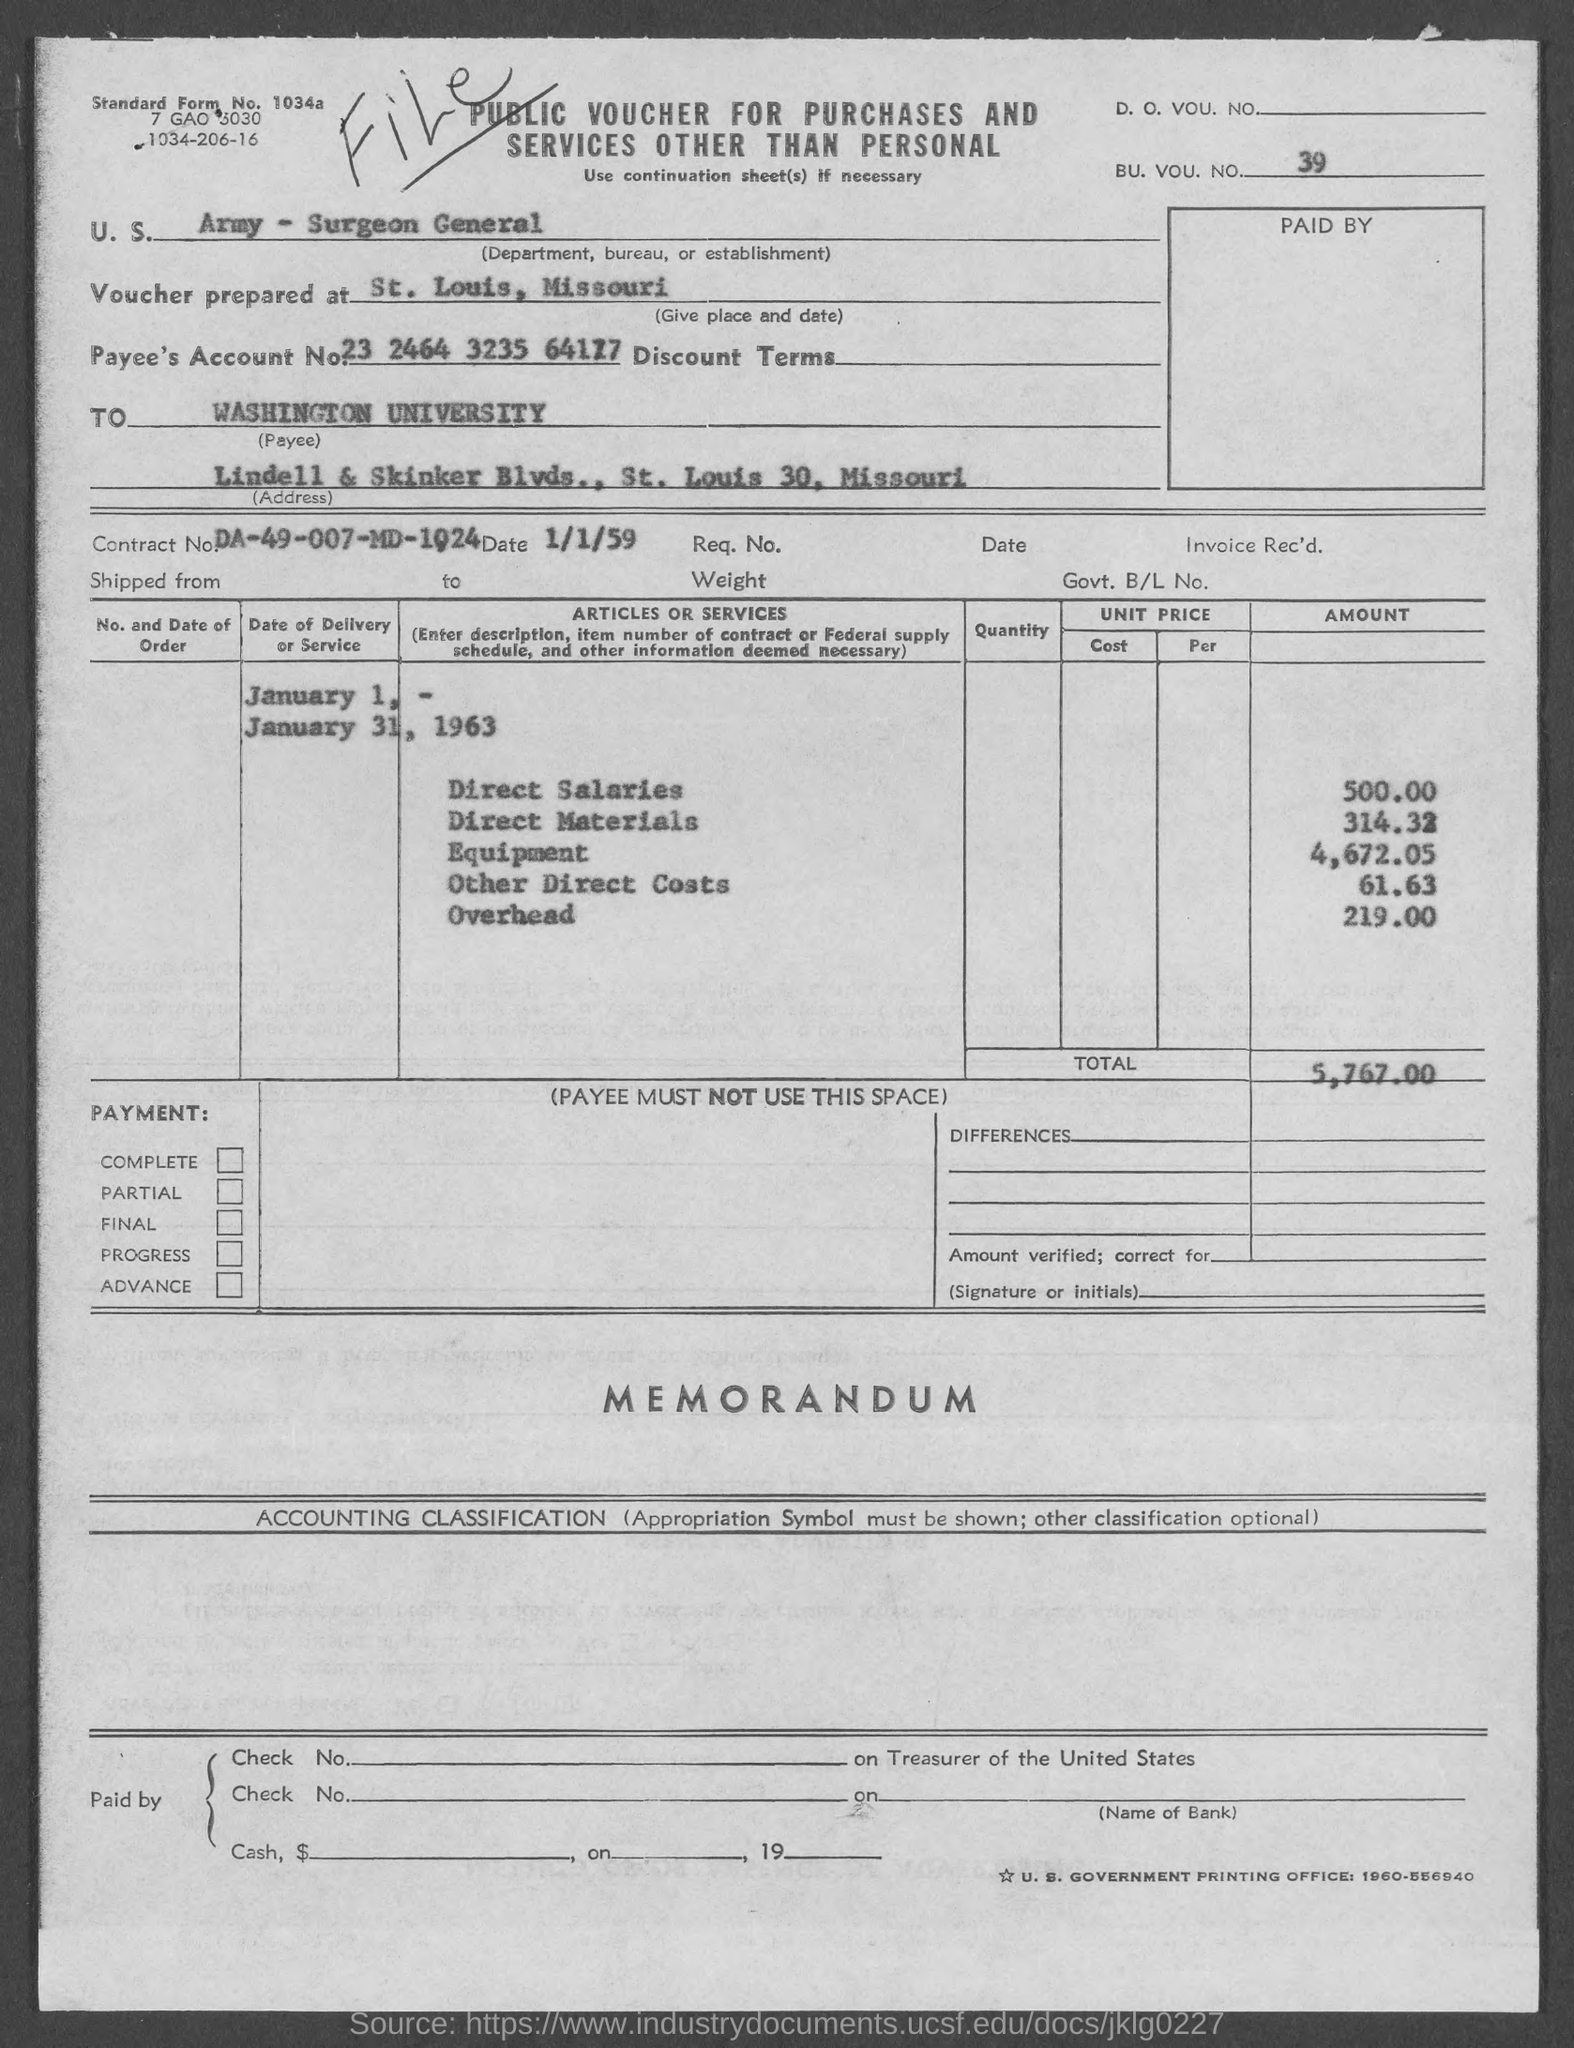Identify some key points in this picture. The total amount specified is 5,767.00. The department mentioned is the army - surgeon general. The question "What is the account number of the payee?" is asking for information about a specific financial account associated with a payee. The account number is 23 2464 3235 64177. This document is a public voucher for the purchase of goods and services, excluding personal items. What is the BU. VOU. NO.? 39.." is a question asking for information about a number, specifically the BU, VOU, and NO components of it. 